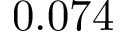<formula> <loc_0><loc_0><loc_500><loc_500>0 . 0 7 4</formula> 